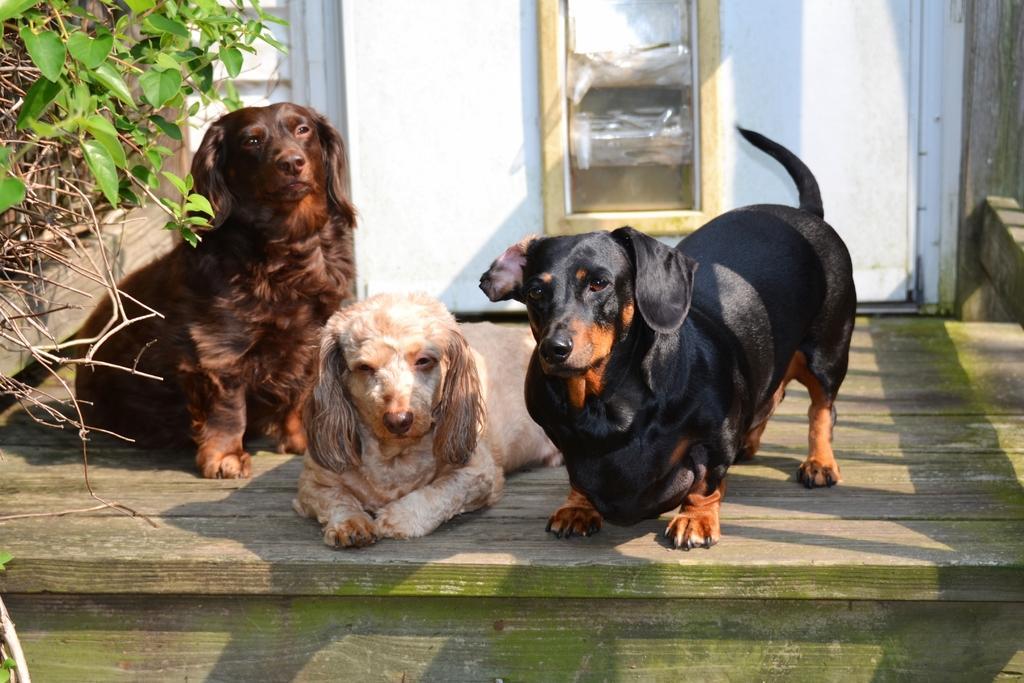Can you describe this image briefly? In the center of the picture there are three dogs. On the left there are plants. In the background there is a door. It is sunny. 